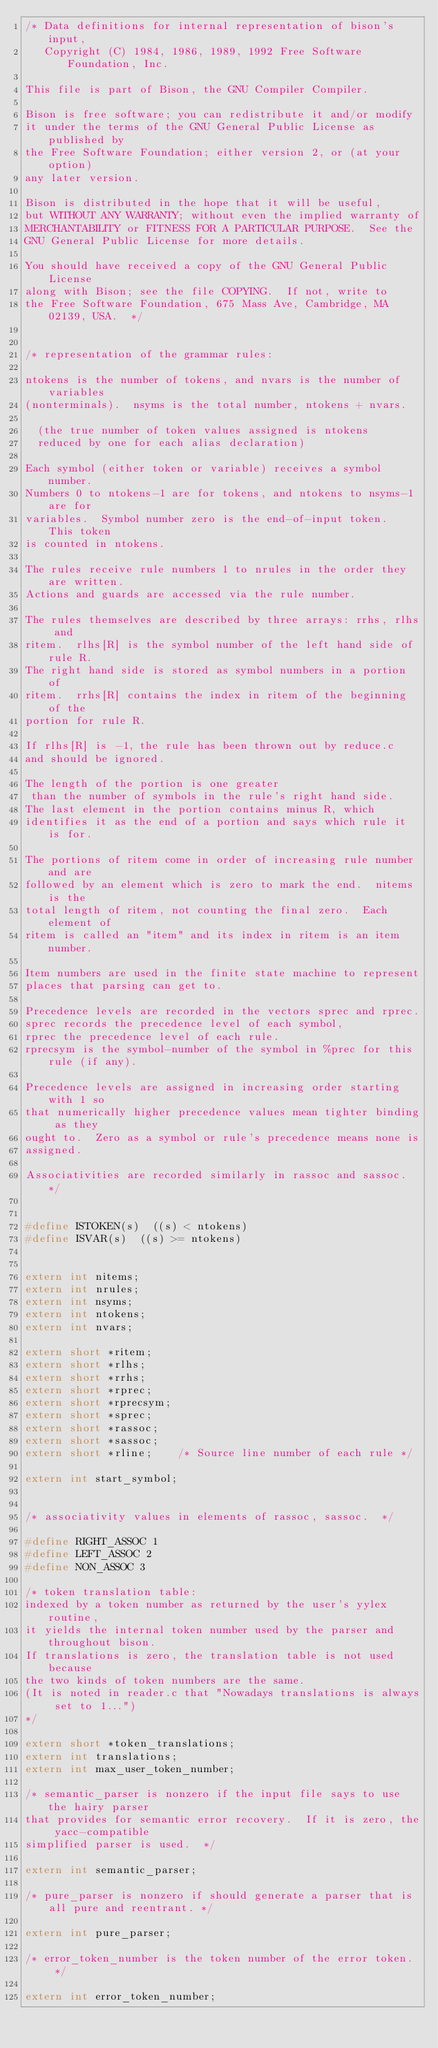Convert code to text. <code><loc_0><loc_0><loc_500><loc_500><_C_>/* Data definitions for internal representation of bison's input,
   Copyright (C) 1984, 1986, 1989, 1992 Free Software Foundation, Inc.

This file is part of Bison, the GNU Compiler Compiler.

Bison is free software; you can redistribute it and/or modify
it under the terms of the GNU General Public License as published by
the Free Software Foundation; either version 2, or (at your option)
any later version.

Bison is distributed in the hope that it will be useful,
but WITHOUT ANY WARRANTY; without even the implied warranty of
MERCHANTABILITY or FITNESS FOR A PARTICULAR PURPOSE.  See the
GNU General Public License for more details.

You should have received a copy of the GNU General Public License
along with Bison; see the file COPYING.  If not, write to
the Free Software Foundation, 675 Mass Ave, Cambridge, MA 02139, USA.  */


/* representation of the grammar rules:

ntokens is the number of tokens, and nvars is the number of variables
(nonterminals).  nsyms is the total number, ntokens + nvars.

	(the true number of token values assigned is ntokens
	reduced by one for each alias declaration)

Each symbol (either token or variable) receives a symbol number.
Numbers 0 to ntokens-1 are for tokens, and ntokens to nsyms-1 are for
variables.  Symbol number zero is the end-of-input token.  This token
is counted in ntokens.

The rules receive rule numbers 1 to nrules in the order they are written.
Actions and guards are accessed via the rule number.

The rules themselves are described by three arrays: rrhs, rlhs and
ritem.  rlhs[R] is the symbol number of the left hand side of rule R.
The right hand side is stored as symbol numbers in a portion of
ritem.  rrhs[R] contains the index in ritem of the beginning of the
portion for rule R.

If rlhs[R] is -1, the rule has been thrown out by reduce.c
and should be ignored.

The length of the portion is one greater
 than the number of symbols in the rule's right hand side.
The last element in the portion contains minus R, which
identifies it as the end of a portion and says which rule it is for.

The portions of ritem come in order of increasing rule number and are
followed by an element which is zero to mark the end.  nitems is the
total length of ritem, not counting the final zero.  Each element of
ritem is called an "item" and its index in ritem is an item number.

Item numbers are used in the finite state machine to represent
places that parsing can get to.

Precedence levels are recorded in the vectors sprec and rprec.
sprec records the precedence level of each symbol,
rprec the precedence level of each rule.
rprecsym is the symbol-number of the symbol in %prec for this rule (if any).

Precedence levels are assigned in increasing order starting with 1 so
that numerically higher precedence values mean tighter binding as they
ought to.  Zero as a symbol or rule's precedence means none is
assigned.

Associativities are recorded similarly in rassoc and sassoc.  */


#define	ISTOKEN(s)	((s) < ntokens)
#define	ISVAR(s)	((s) >= ntokens)


extern int nitems;
extern int nrules;
extern int nsyms;
extern int ntokens;
extern int nvars;

extern short *ritem;
extern short *rlhs;
extern short *rrhs;
extern short *rprec;
extern short *rprecsym;
extern short *sprec;
extern short *rassoc;
extern short *sassoc;
extern short *rline;		/* Source line number of each rule */

extern int start_symbol;


/* associativity values in elements of rassoc, sassoc.  */

#define RIGHT_ASSOC 1
#define LEFT_ASSOC 2
#define NON_ASSOC 3

/* token translation table:
indexed by a token number as returned by the user's yylex routine,
it yields the internal token number used by the parser and throughout bison.
If translations is zero, the translation table is not used because
the two kinds of token numbers are the same.  
(It is noted in reader.c that "Nowadays translations is always set to 1...")
*/

extern short *token_translations;
extern int translations;
extern int max_user_token_number;

/* semantic_parser is nonzero if the input file says to use the hairy parser
that provides for semantic error recovery.  If it is zero, the yacc-compatible
simplified parser is used.  */

extern int semantic_parser;

/* pure_parser is nonzero if should generate a parser that is all pure and reentrant. */

extern int pure_parser;

/* error_token_number is the token number of the error token.  */

extern int error_token_number;
</code> 